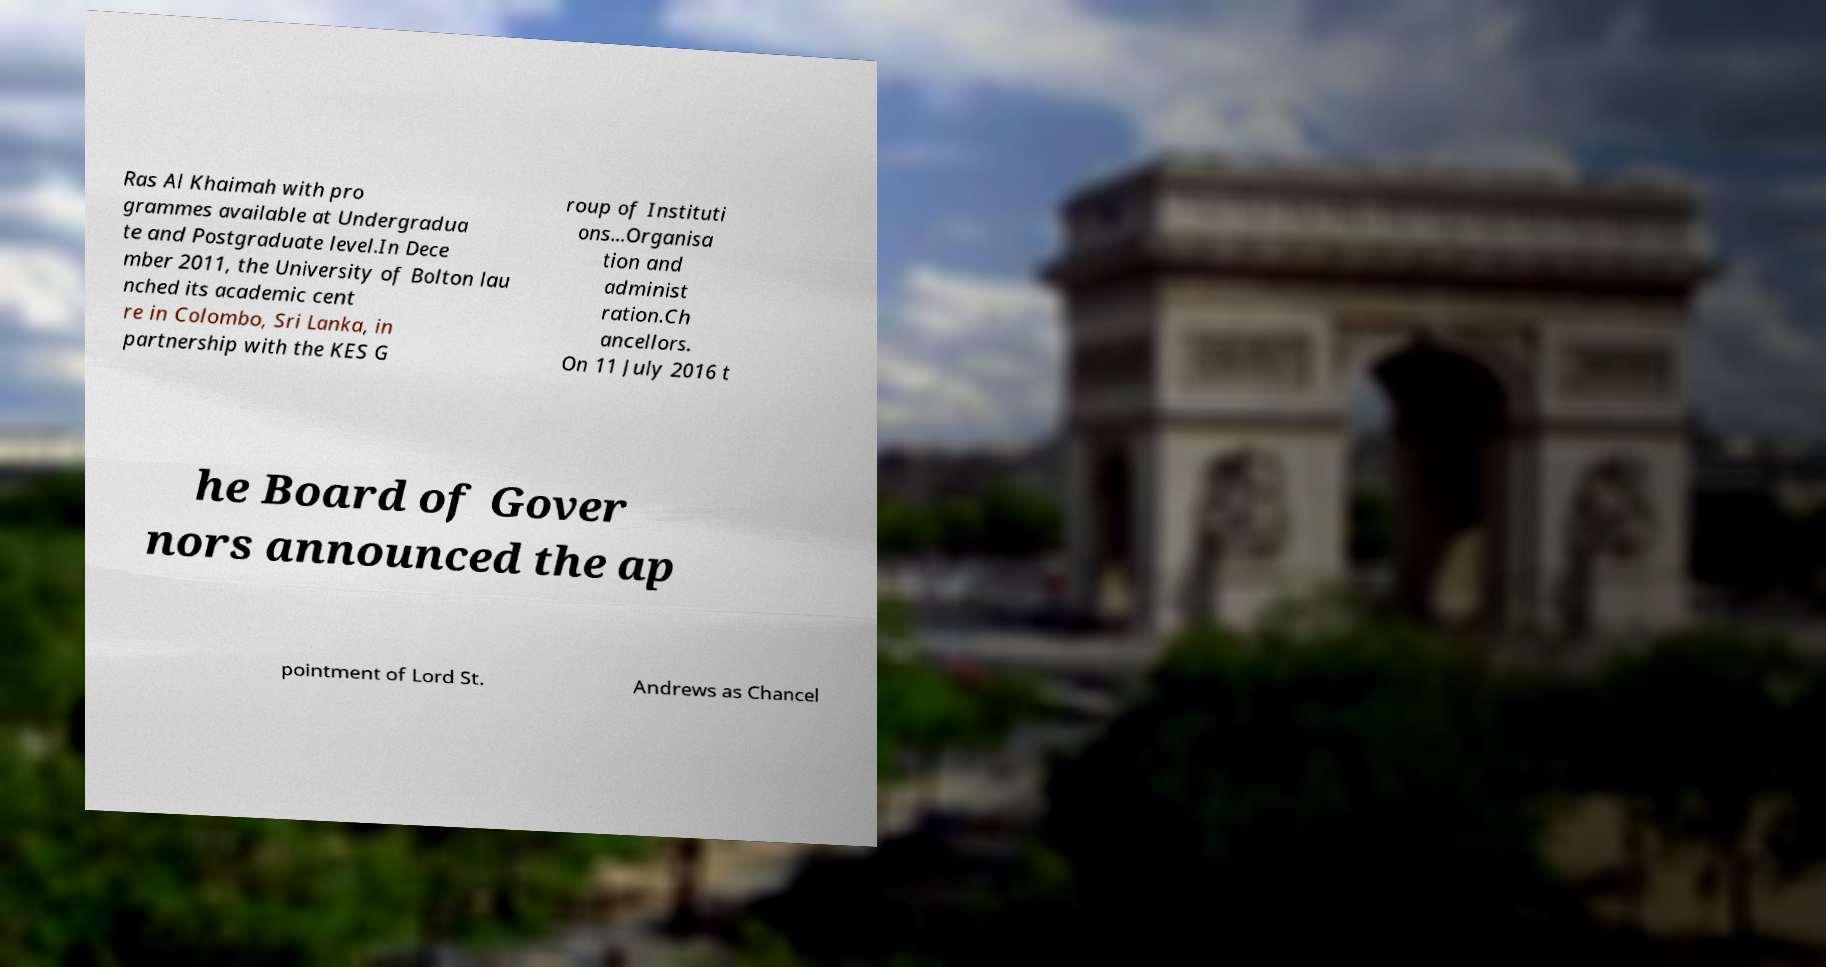I need the written content from this picture converted into text. Can you do that? Ras Al Khaimah with pro grammes available at Undergradua te and Postgraduate level.In Dece mber 2011, the University of Bolton lau nched its academic cent re in Colombo, Sri Lanka, in partnership with the KES G roup of Instituti ons...Organisa tion and administ ration.Ch ancellors. On 11 July 2016 t he Board of Gover nors announced the ap pointment of Lord St. Andrews as Chancel 